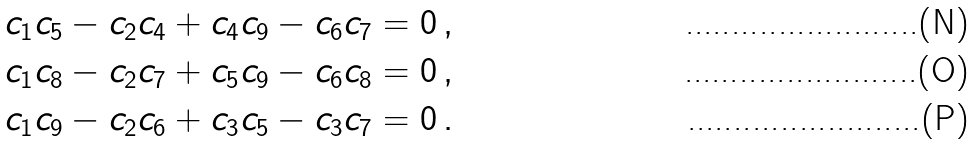Convert formula to latex. <formula><loc_0><loc_0><loc_500><loc_500>& c _ { 1 } c _ { 5 } - c _ { 2 } c _ { 4 } + c _ { 4 } c _ { 9 } - c _ { 6 } c _ { 7 } = 0 \, , \\ & c _ { 1 } c _ { 8 } - c _ { 2 } c _ { 7 } + c _ { 5 } c _ { 9 } - c _ { 6 } c _ { 8 } = 0 \, , \\ & c _ { 1 } c _ { 9 } - c _ { 2 } c _ { 6 } + c _ { 3 } c _ { 5 } - c _ { 3 } c _ { 7 } = 0 \, .</formula> 